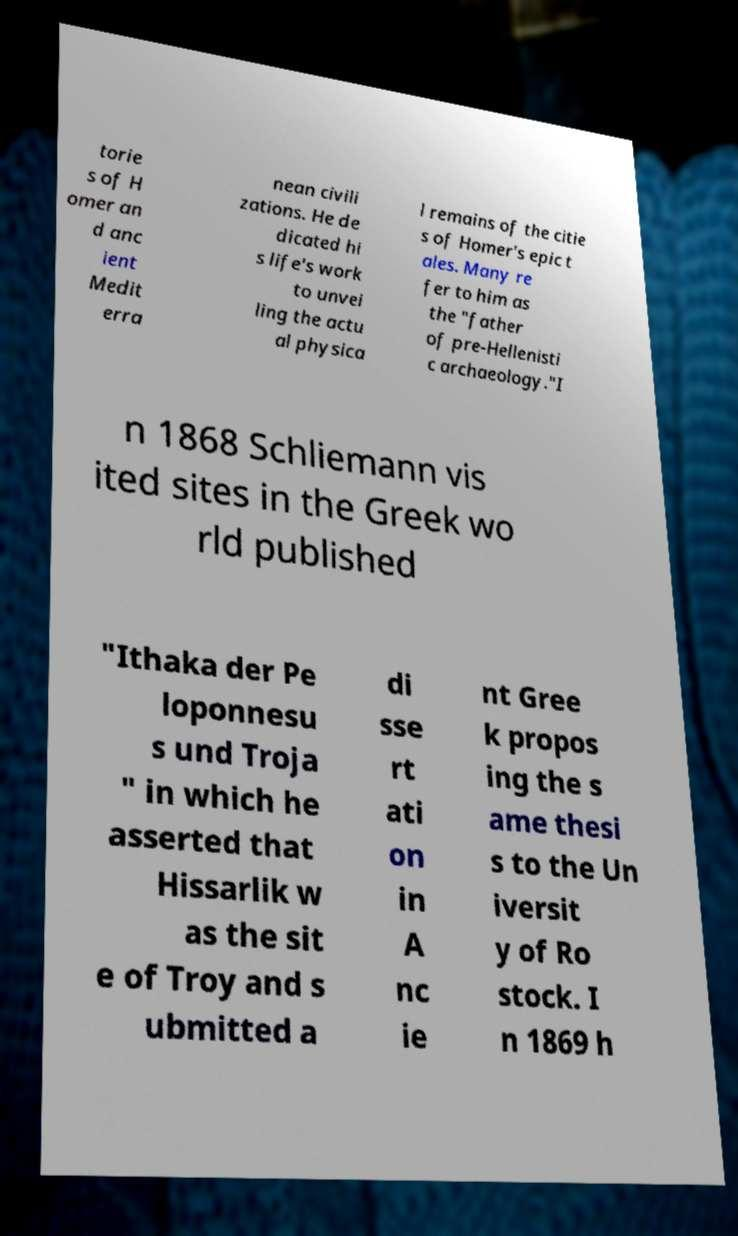Could you extract and type out the text from this image? torie s of H omer an d anc ient Medit erra nean civili zations. He de dicated hi s life's work to unvei ling the actu al physica l remains of the citie s of Homer's epic t ales. Many re fer to him as the "father of pre-Hellenisti c archaeology."I n 1868 Schliemann vis ited sites in the Greek wo rld published "Ithaka der Pe loponnesu s und Troja " in which he asserted that Hissarlik w as the sit e of Troy and s ubmitted a di sse rt ati on in A nc ie nt Gree k propos ing the s ame thesi s to the Un iversit y of Ro stock. I n 1869 h 